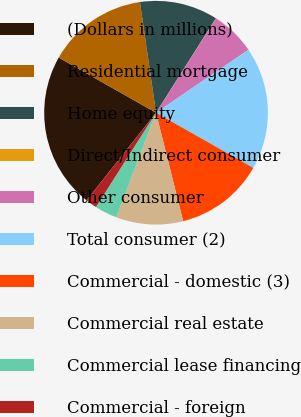Convert chart. <chart><loc_0><loc_0><loc_500><loc_500><pie_chart><fcel>(Dollars in millions)<fcel>Residential mortgage<fcel>Home equity<fcel>Direct/Indirect consumer<fcel>Other consumer<fcel>Total consumer (2)<fcel>Commercial - domestic (3)<fcel>Commercial real estate<fcel>Commercial lease financing<fcel>Commercial - foreign<nl><fcel>22.54%<fcel>14.5%<fcel>11.29%<fcel>0.03%<fcel>6.46%<fcel>17.72%<fcel>12.89%<fcel>9.68%<fcel>3.25%<fcel>1.64%<nl></chart> 